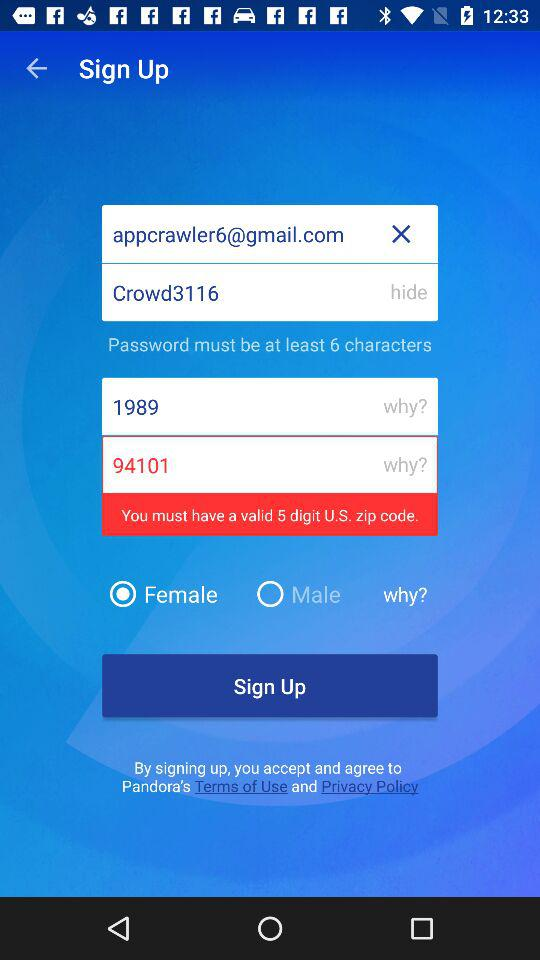Which gender is selected? The selected gender is female. 